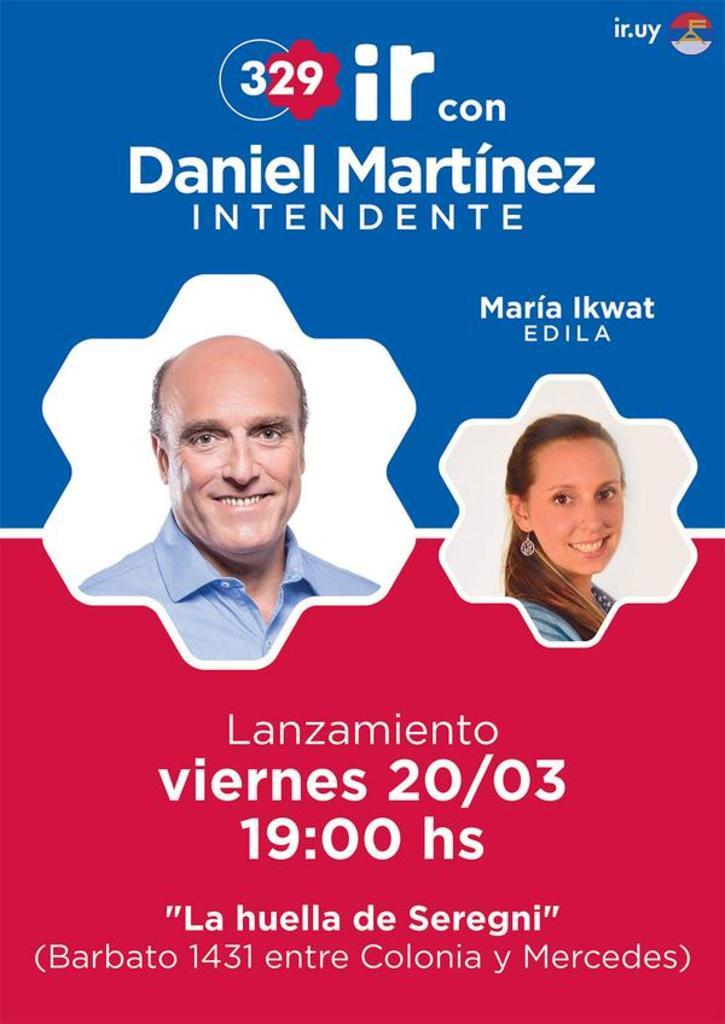How many people are present in the image? There are two people, a man and a woman, present in the image. What can be seen in addition to the man and woman? There is some text in the image. Can you describe the text in the image? Unfortunately, the details of the text are not provided in the facts, so it cannot be described. How many bees can be seen flying around the man in the image? There are no bees present in the image; it only features a man, a woman, and some text. 